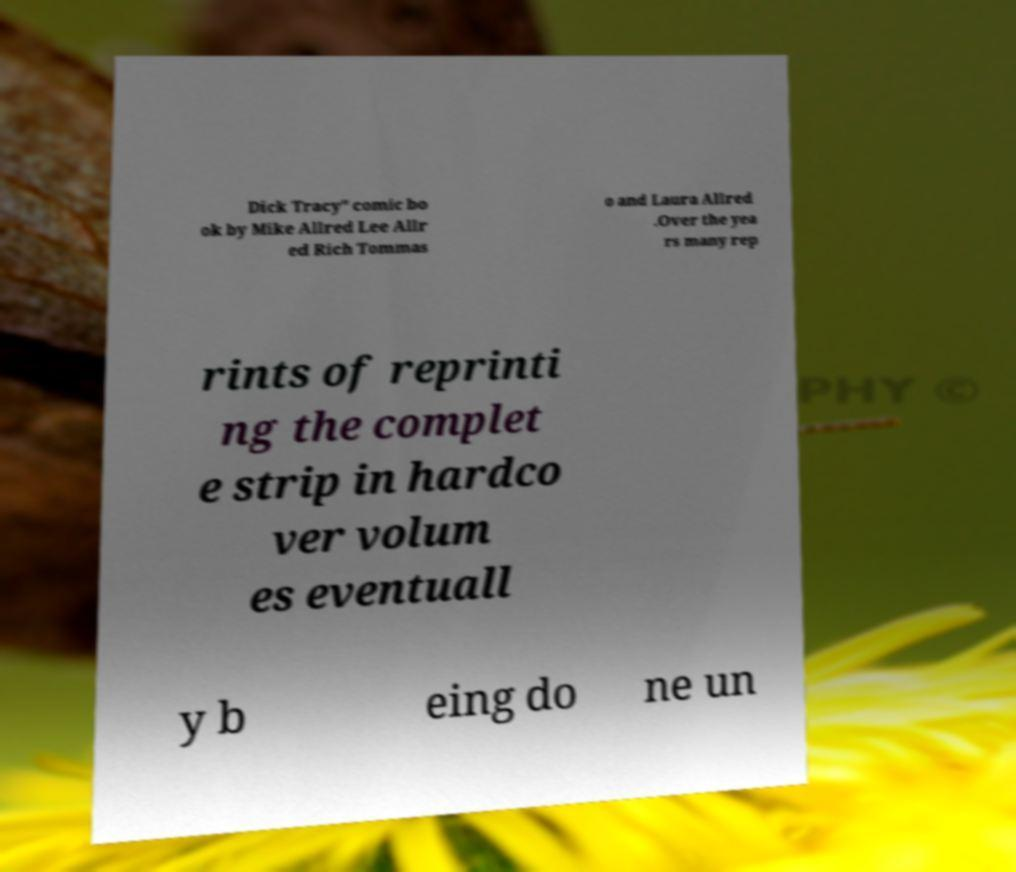What messages or text are displayed in this image? I need them in a readable, typed format. Dick Tracy" comic bo ok by Mike Allred Lee Allr ed Rich Tommas o and Laura Allred .Over the yea rs many rep rints of reprinti ng the complet e strip in hardco ver volum es eventuall y b eing do ne un 